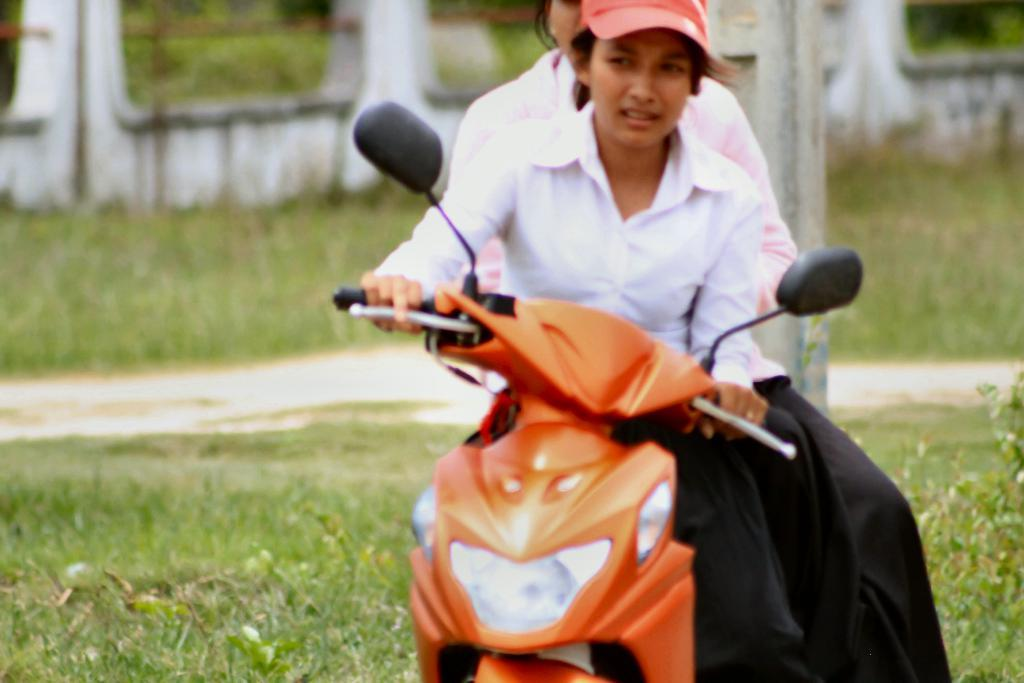How many people are in the image? There are two persons in the image. What are the two persons doing in the image? The two persons are sitting on a motorbike. What can be seen in the background of the image? There is grass, a pole, and a wall in the background of the image. What type of tomatoes are growing on the vest of the person on the left? There are no tomatoes or vests present in the image. 